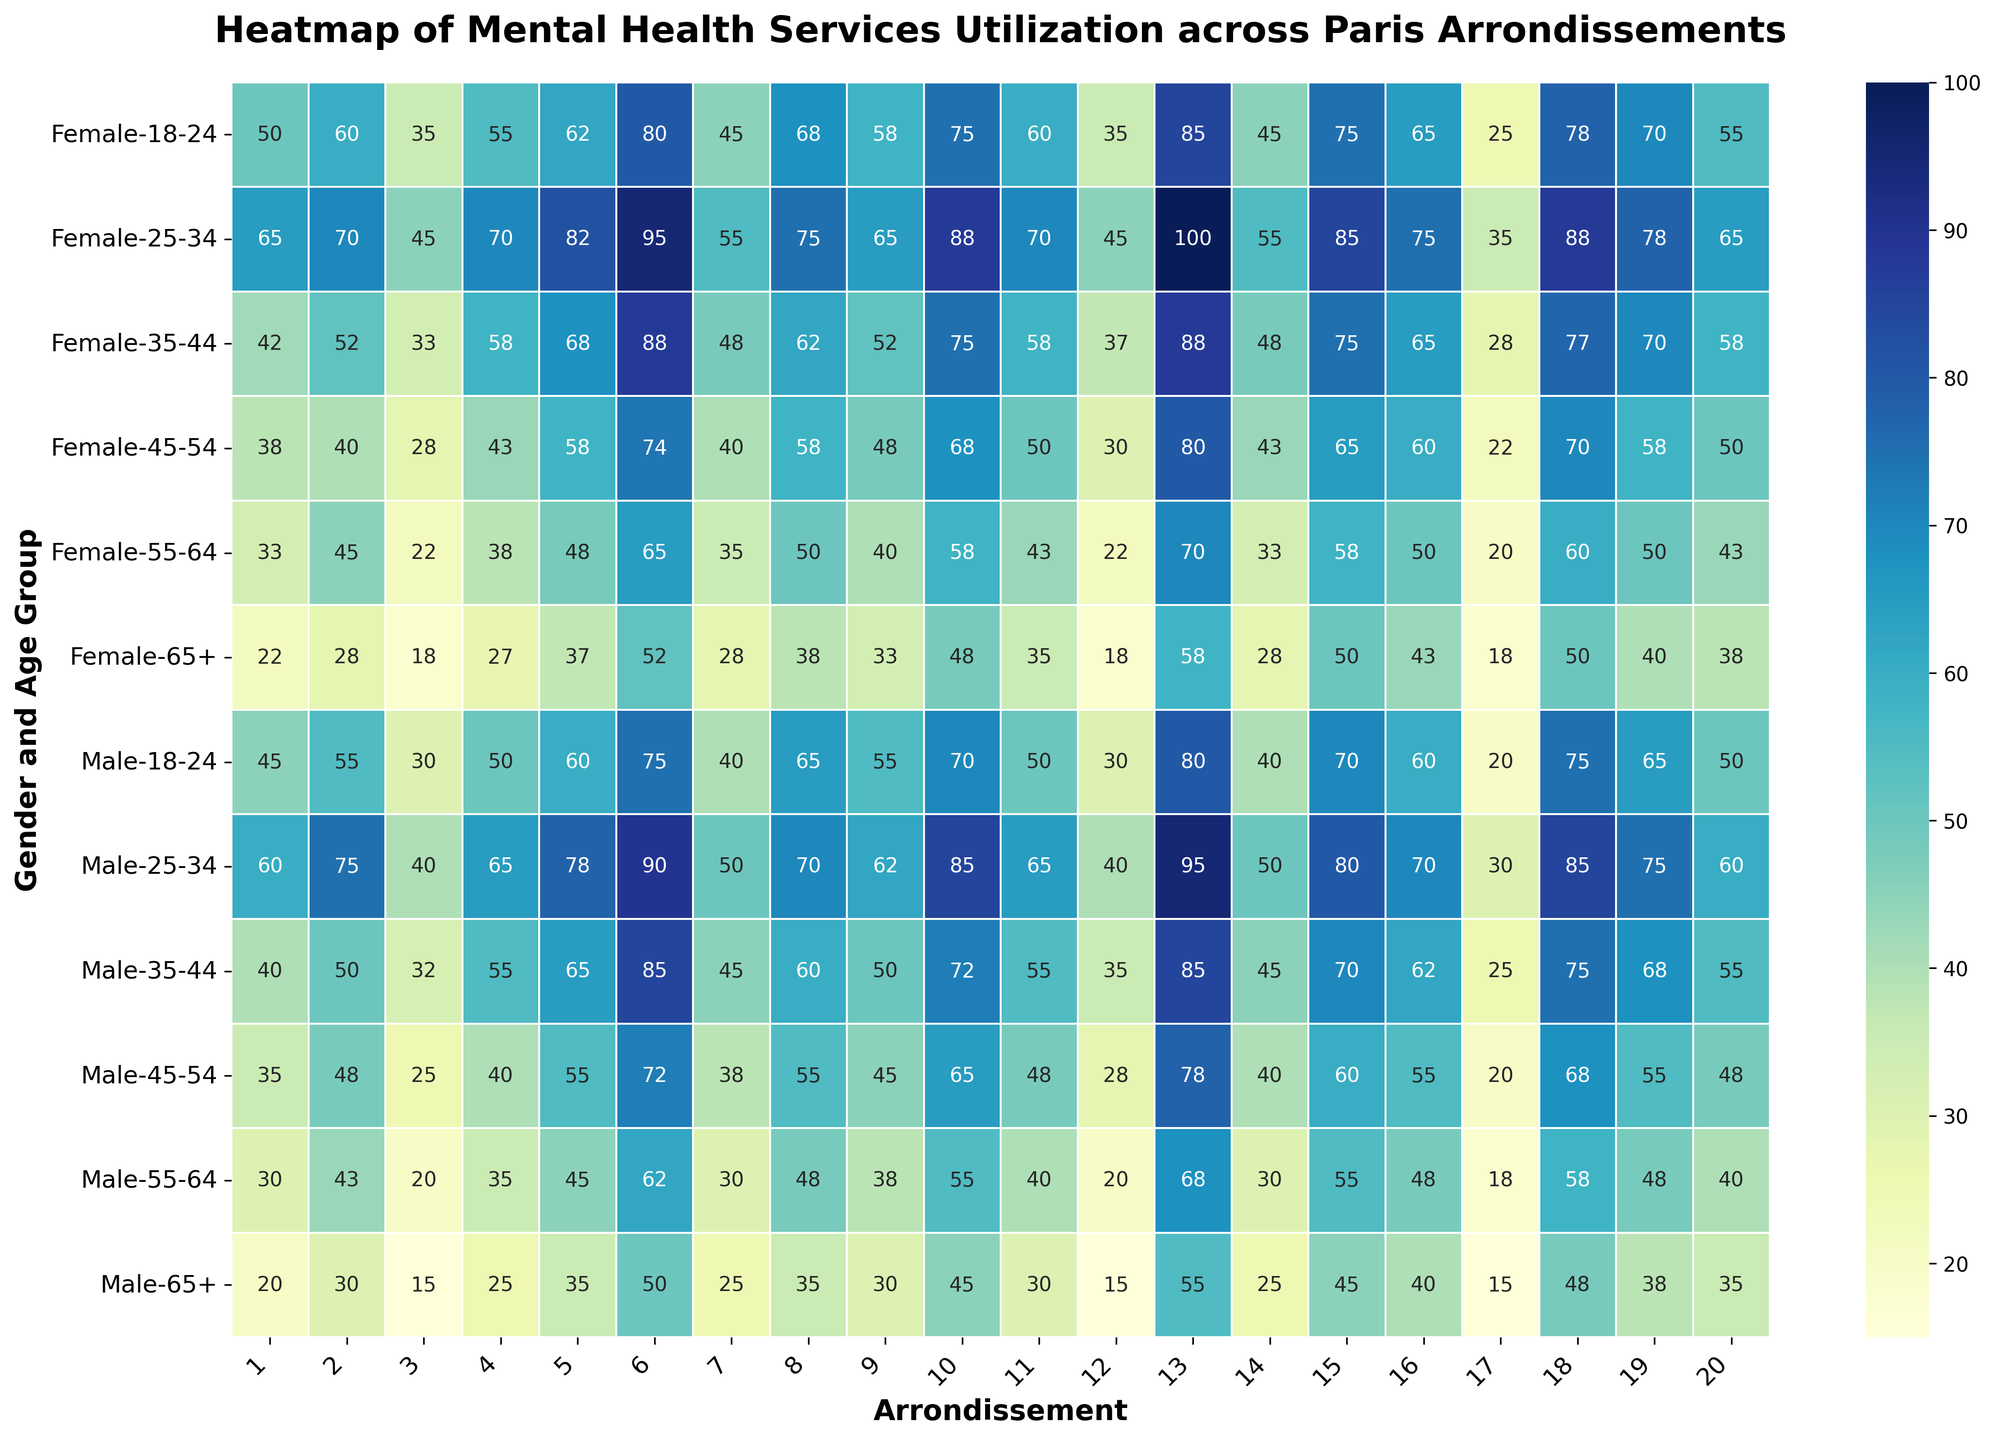Which arrondissement shows the highest utilization of mental health services for females aged 25-34? Locate the row corresponding to females aged 25-34, then identify the highest value in this row, which corresponds to the 13th arrondissement.
Answer: 13th arrondissement What is the difference in mental health services utilization between males aged 55-64 and females aged 55-64 in the 10th arrondissement? Find the values for males and females aged 55-64 in the 10th arrondissement, which are 55 and 58, respectively. Subtract the male value from the female value: 58 - 55.
Answer: 3 Which gender and age group has the lowest mental health services utilization in the 17th arrondissement? Look at the 17th arrondissement column and compare utilization values. The lowest value is for females aged 65+, with a utilization of 18.
Answer: Females aged 65+ Compare the utilization of mental health services for females aged 45-54 in the 8th and 6th arrondissements. Which one is higher? Find the values for females aged 45-54 in the 8th (58) and 6th (74) arrondissements, and compare them to see that the 6th arrondissement has a higher utilization.
Answer: 6th arrondissement What is the average utilization of mental health services for males aged 25-34 across all arrondissements? Find the values in the row for males aged 25-34, add them up: 60 + 75 + 40 + 65 + 78 + 90 + 50 + 70 + 62 + 85 + 65 + 40 + 95 + 50 + 80 + 70 + 30 + 85 + 75 + 60 = 1358. Divide by the number of arrondissements (20): 1358/20.
Answer: 67.9 Are there any age groups with equal utilization of mental health services between males and females in the same arrondissement? If so, name one. Compare the values for males and females within each age group and arrondissement. In the 2nd arrondissement, both males and females aged 18-24 have equal utilization values of 60.
Answer: 18-24 age group in the 2nd arrondissement In which arrondissement is the utilization of mental health services by males aged 18-24 closest to 70? Check the values for males aged 18-24, and find which one is closest to 70. The 10th arrondissement has a utilization value of 70.
Answer: 10th arrondissement What is the total utilization value of mental health services for females aged 35-44 across all arrondissements? Sum the values in the row for females aged 35-44: 42 + 52 + 33 + 58 + 68 + 88 + 48 + 62 + 52 + 75 + 58 + 37 + 88 + 48 + 75 + 65 + 28 + 77 + 70 + 58 = 1144.
Answer: 1144 